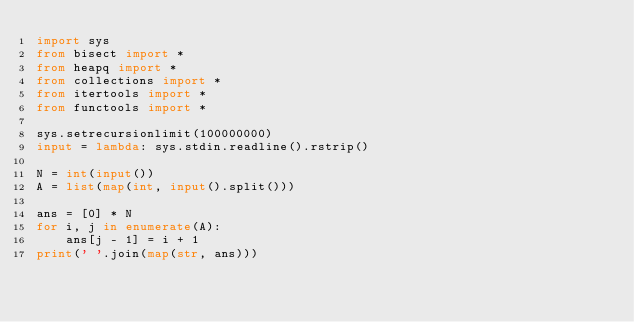<code> <loc_0><loc_0><loc_500><loc_500><_Python_>import sys
from bisect import *
from heapq import *
from collections import *
from itertools import *
from functools import *

sys.setrecursionlimit(100000000)
input = lambda: sys.stdin.readline().rstrip()

N = int(input())
A = list(map(int, input().split()))

ans = [0] * N
for i, j in enumerate(A):
    ans[j - 1] = i + 1
print(' '.join(map(str, ans)))</code> 